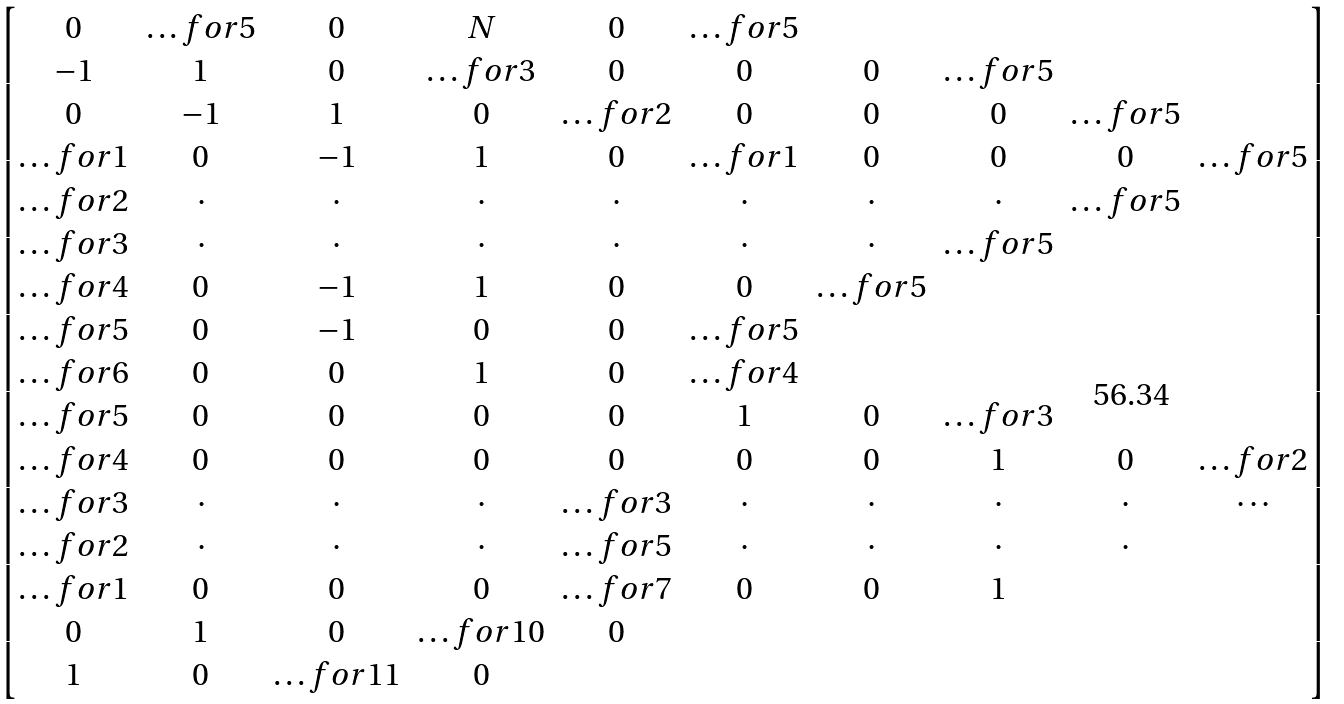Convert formula to latex. <formula><loc_0><loc_0><loc_500><loc_500>\begin{bmatrix} 0 & \hdots f o r { 5 } & 0 & N & 0 & \hdots f o r { 5 } \\ - 1 & 1 & 0 & \hdots f o r { 3 } & 0 & 0 & 0 & \hdots f o r { 5 } \\ 0 & - 1 & 1 & 0 & \hdots f o r { 2 } & 0 & 0 & 0 & \hdots f o r { 5 } \\ \hdots f o r { 1 } & 0 & - 1 & 1 & 0 & \hdots f o r { 1 } & 0 & 0 & 0 & \hdots f o r { 5 } \\ \hdots f o r { 2 } & \cdot & \cdot & \cdot & \cdot & \cdot & \cdot & \cdot & \hdots f o r { 5 } \\ \hdots f o r { 3 } & \cdot & \cdot & \cdot & \cdot & \cdot & \cdot & \hdots f o r { 5 } \\ \hdots f o r { 4 } & 0 & - 1 & 1 & 0 & 0 & \hdots f o r { 5 } \\ \hdots f o r { 5 } & 0 & - 1 & 0 & 0 & \hdots f o r { 5 } \\ \hdots f o r { 6 } & 0 & 0 & 1 & 0 & \hdots f o r { 4 } \\ \hdots f o r { 5 } & 0 & 0 & 0 & 0 & 1 & 0 & \hdots f o r { 3 } \\ \hdots f o r { 4 } & 0 & 0 & 0 & 0 & 0 & 0 & 1 & 0 & \hdots f o r { 2 } \\ \hdots f o r { 3 } & \cdot & \cdot & \cdot & \hdots f o r { 3 } & \cdot & \cdot & \cdot & \cdot & \cdots \\ \hdots f o r { 2 } & \cdot & \cdot & \cdot & \hdots f o r { 5 } & \cdot & \cdot & \cdot & \cdot \\ \hdots f o r { 1 } & 0 & 0 & 0 & \hdots f o r { 7 } & 0 & 0 & 1 \\ 0 & 1 & 0 & \hdots f o r { 1 0 } & 0 \\ 1 & 0 & \hdots f o r { 1 1 } & 0 \end{bmatrix}</formula> 